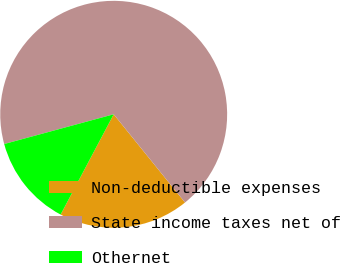Convert chart to OTSL. <chart><loc_0><loc_0><loc_500><loc_500><pie_chart><fcel>Non-deductible expenses<fcel>State income taxes net of<fcel>Othernet<nl><fcel>18.57%<fcel>68.4%<fcel>13.03%<nl></chart> 